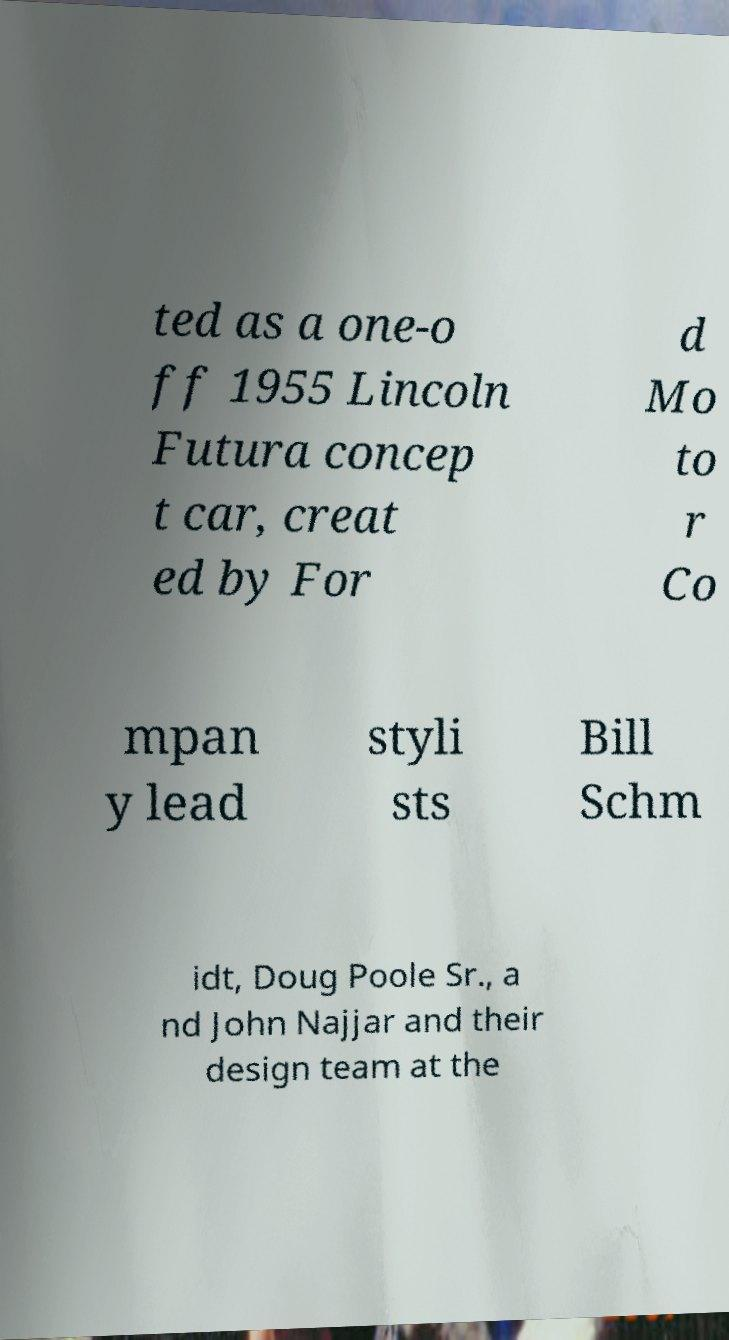Can you read and provide the text displayed in the image?This photo seems to have some interesting text. Can you extract and type it out for me? ted as a one-o ff 1955 Lincoln Futura concep t car, creat ed by For d Mo to r Co mpan y lead styli sts Bill Schm idt, Doug Poole Sr., a nd John Najjar and their design team at the 